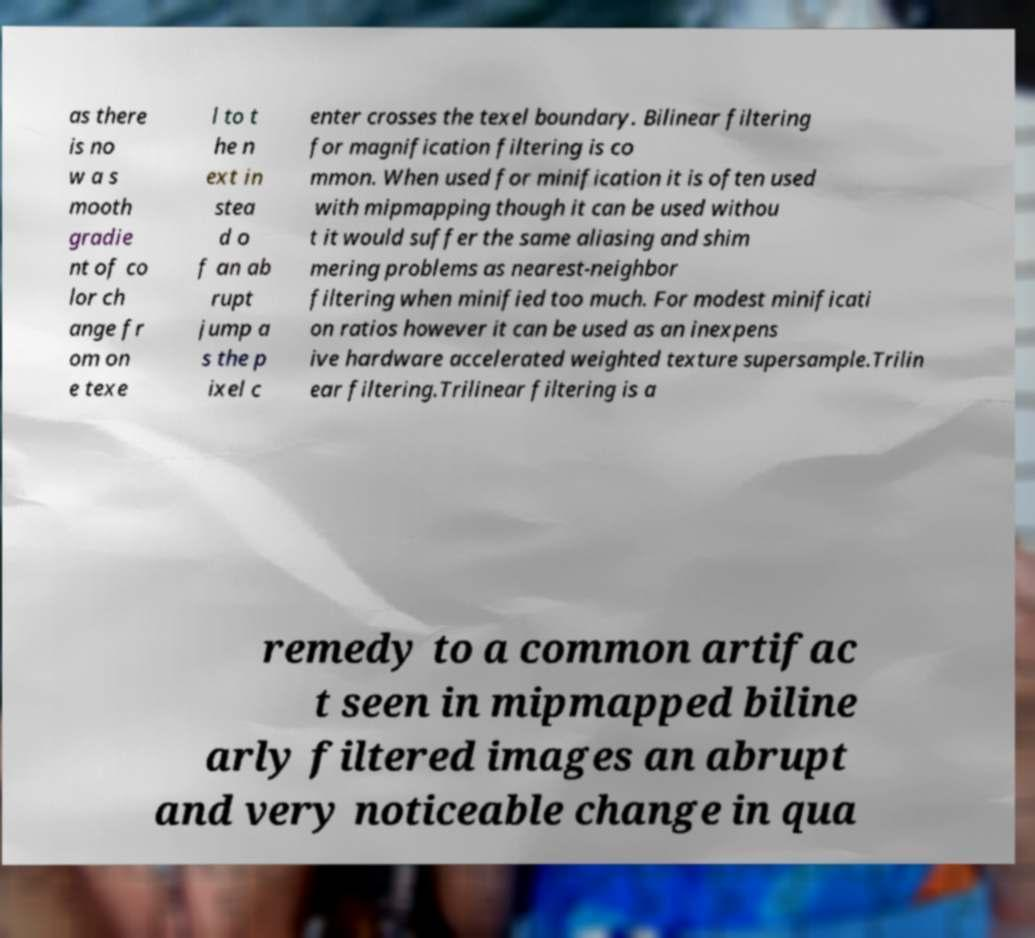What messages or text are displayed in this image? I need them in a readable, typed format. as there is no w a s mooth gradie nt of co lor ch ange fr om on e texe l to t he n ext in stea d o f an ab rupt jump a s the p ixel c enter crosses the texel boundary. Bilinear filtering for magnification filtering is co mmon. When used for minification it is often used with mipmapping though it can be used withou t it would suffer the same aliasing and shim mering problems as nearest-neighbor filtering when minified too much. For modest minificati on ratios however it can be used as an inexpens ive hardware accelerated weighted texture supersample.Trilin ear filtering.Trilinear filtering is a remedy to a common artifac t seen in mipmapped biline arly filtered images an abrupt and very noticeable change in qua 